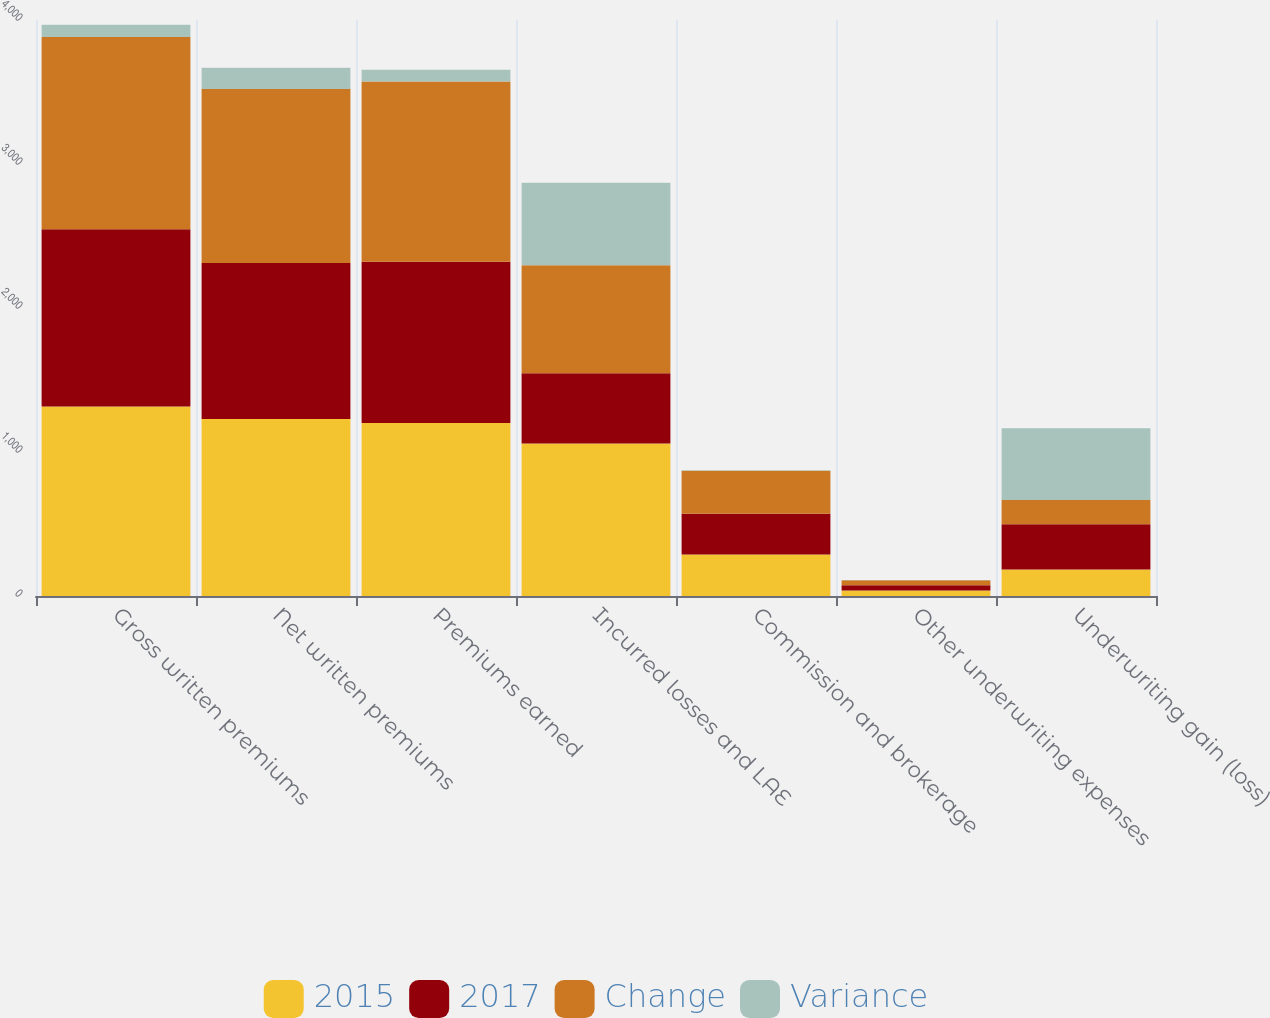Convert chart to OTSL. <chart><loc_0><loc_0><loc_500><loc_500><stacked_bar_chart><ecel><fcel>Gross written premiums<fcel>Net written premiums<fcel>Premiums earned<fcel>Incurred losses and LAE<fcel>Commission and brokerage<fcel>Other underwriting expenses<fcel>Underwriting gain (loss)<nl><fcel>2015<fcel>1316.7<fcel>1229.6<fcel>1202<fcel>1059.6<fcel>287.7<fcel>38.8<fcel>184.1<nl><fcel>2017<fcel>1230.7<fcel>1082.7<fcel>1119.1<fcel>486.6<fcel>283.4<fcel>35.5<fcel>313.6<nl><fcel>Change<fcel>1334.2<fcel>1209<fcel>1251.1<fcel>749.9<fcel>298.2<fcel>34.3<fcel>168.7<nl><fcel>Variance<fcel>86<fcel>146.9<fcel>82.9<fcel>573.1<fcel>4.2<fcel>3.3<fcel>497.7<nl></chart> 